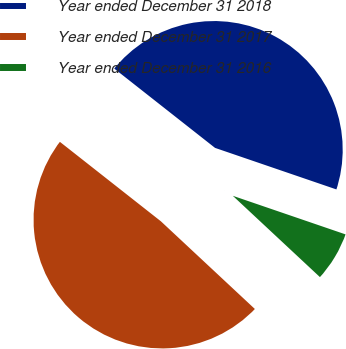Convert chart to OTSL. <chart><loc_0><loc_0><loc_500><loc_500><pie_chart><fcel>Year ended December 31 2018<fcel>Year ended December 31 2017<fcel>Year ended December 31 2016<nl><fcel>44.64%<fcel>48.66%<fcel>6.7%<nl></chart> 